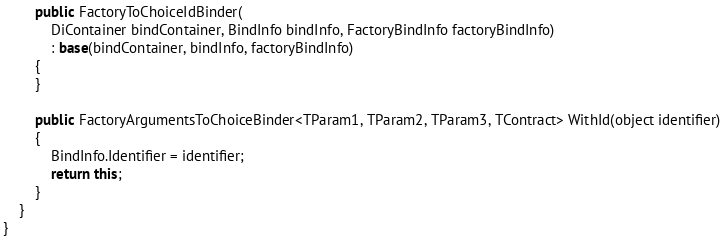<code> <loc_0><loc_0><loc_500><loc_500><_C#_>        public FactoryToChoiceIdBinder(
            DiContainer bindContainer, BindInfo bindInfo, FactoryBindInfo factoryBindInfo)
            : base(bindContainer, bindInfo, factoryBindInfo)
        {
        }

        public FactoryArgumentsToChoiceBinder<TParam1, TParam2, TParam3, TContract> WithId(object identifier)
        {
            BindInfo.Identifier = identifier;
            return this;
        }
    }
}


</code> 